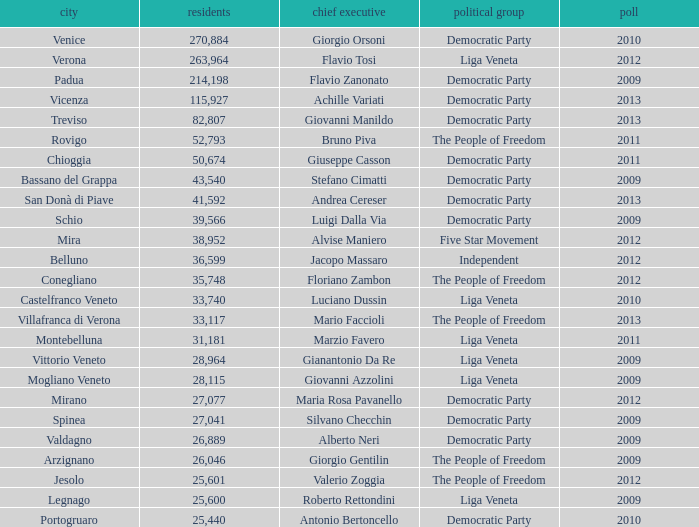How many elections had more than 36,599 inhabitants when Mayor was giovanni manildo? 1.0. 